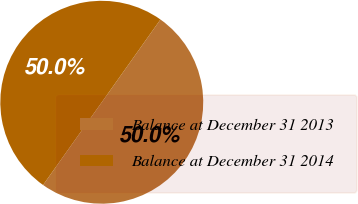Convert chart to OTSL. <chart><loc_0><loc_0><loc_500><loc_500><pie_chart><fcel>Balance at December 31 2013<fcel>Balance at December 31 2014<nl><fcel>50.0%<fcel>50.0%<nl></chart> 